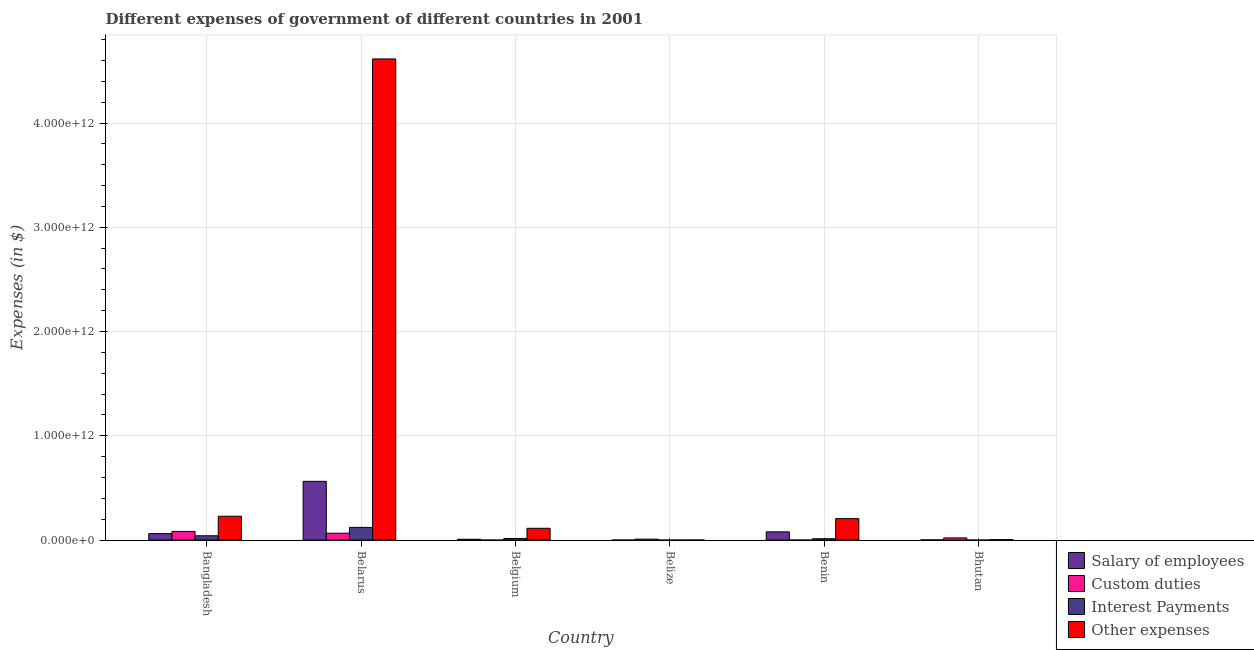Are the number of bars per tick equal to the number of legend labels?
Ensure brevity in your answer.  Yes. Are the number of bars on each tick of the X-axis equal?
Keep it short and to the point. Yes. How many bars are there on the 6th tick from the right?
Your answer should be very brief. 4. What is the label of the 6th group of bars from the left?
Give a very brief answer. Bhutan. In how many cases, is the number of bars for a given country not equal to the number of legend labels?
Offer a terse response. 0. What is the amount spent on custom duties in Belarus?
Offer a terse response. 6.60e+1. Across all countries, what is the maximum amount spent on salary of employees?
Provide a short and direct response. 5.64e+11. Across all countries, what is the minimum amount spent on interest payments?
Keep it short and to the point. 5.36e+07. In which country was the amount spent on other expenses maximum?
Provide a short and direct response. Belarus. In which country was the amount spent on custom duties minimum?
Give a very brief answer. Belgium. What is the total amount spent on other expenses in the graph?
Make the answer very short. 5.17e+12. What is the difference between the amount spent on interest payments in Belarus and that in Bhutan?
Your answer should be very brief. 1.22e+11. What is the difference between the amount spent on other expenses in Belarus and the amount spent on salary of employees in Belgium?
Your answer should be very brief. 4.61e+12. What is the average amount spent on interest payments per country?
Make the answer very short. 3.20e+1. What is the difference between the amount spent on salary of employees and amount spent on other expenses in Belize?
Your response must be concise. -2.12e+08. What is the ratio of the amount spent on interest payments in Belgium to that in Benin?
Give a very brief answer. 1.18. Is the difference between the amount spent on salary of employees in Bangladesh and Bhutan greater than the difference between the amount spent on custom duties in Bangladesh and Bhutan?
Ensure brevity in your answer.  No. What is the difference between the highest and the second highest amount spent on salary of employees?
Provide a short and direct response. 4.85e+11. What is the difference between the highest and the lowest amount spent on salary of employees?
Provide a short and direct response. 5.63e+11. Is the sum of the amount spent on interest payments in Belgium and Belize greater than the maximum amount spent on custom duties across all countries?
Offer a very short reply. No. Is it the case that in every country, the sum of the amount spent on custom duties and amount spent on salary of employees is greater than the sum of amount spent on interest payments and amount spent on other expenses?
Ensure brevity in your answer.  No. What does the 1st bar from the left in Benin represents?
Ensure brevity in your answer.  Salary of employees. What does the 1st bar from the right in Belarus represents?
Ensure brevity in your answer.  Other expenses. How many countries are there in the graph?
Make the answer very short. 6. What is the difference between two consecutive major ticks on the Y-axis?
Provide a short and direct response. 1.00e+12. Are the values on the major ticks of Y-axis written in scientific E-notation?
Your answer should be very brief. Yes. Does the graph contain any zero values?
Your answer should be very brief. No. Where does the legend appear in the graph?
Your answer should be compact. Bottom right. What is the title of the graph?
Keep it short and to the point. Different expenses of government of different countries in 2001. Does "Manufacturing" appear as one of the legend labels in the graph?
Keep it short and to the point. No. What is the label or title of the Y-axis?
Ensure brevity in your answer.  Expenses (in $). What is the Expenses (in $) of Salary of employees in Bangladesh?
Offer a very short reply. 6.23e+1. What is the Expenses (in $) in Custom duties in Bangladesh?
Provide a succinct answer. 8.33e+1. What is the Expenses (in $) of Interest Payments in Bangladesh?
Your answer should be very brief. 4.15e+1. What is the Expenses (in $) of Other expenses in Bangladesh?
Your answer should be compact. 2.29e+11. What is the Expenses (in $) in Salary of employees in Belarus?
Your response must be concise. 5.64e+11. What is the Expenses (in $) in Custom duties in Belarus?
Give a very brief answer. 6.60e+1. What is the Expenses (in $) of Interest Payments in Belarus?
Ensure brevity in your answer.  1.22e+11. What is the Expenses (in $) in Other expenses in Belarus?
Ensure brevity in your answer.  4.61e+12. What is the Expenses (in $) of Salary of employees in Belgium?
Give a very brief answer. 7.92e+09. What is the Expenses (in $) of Custom duties in Belgium?
Keep it short and to the point. 7.83e+07. What is the Expenses (in $) of Interest Payments in Belgium?
Offer a terse response. 1.55e+1. What is the Expenses (in $) in Other expenses in Belgium?
Make the answer very short. 1.13e+11. What is the Expenses (in $) of Salary of employees in Belize?
Your response must be concise. 1.64e+08. What is the Expenses (in $) in Custom duties in Belize?
Make the answer very short. 9.09e+09. What is the Expenses (in $) of Interest Payments in Belize?
Provide a short and direct response. 5.36e+07. What is the Expenses (in $) in Other expenses in Belize?
Your answer should be very brief. 3.75e+08. What is the Expenses (in $) of Salary of employees in Benin?
Offer a very short reply. 7.91e+1. What is the Expenses (in $) in Custom duties in Benin?
Keep it short and to the point. 1.95e+08. What is the Expenses (in $) of Interest Payments in Benin?
Provide a short and direct response. 1.32e+1. What is the Expenses (in $) of Other expenses in Benin?
Provide a short and direct response. 2.06e+11. What is the Expenses (in $) of Salary of employees in Bhutan?
Your answer should be compact. 1.72e+09. What is the Expenses (in $) of Custom duties in Bhutan?
Provide a short and direct response. 2.11e+1. What is the Expenses (in $) of Interest Payments in Bhutan?
Provide a succinct answer. 7.78e+07. What is the Expenses (in $) in Other expenses in Bhutan?
Your answer should be compact. 4.54e+09. Across all countries, what is the maximum Expenses (in $) of Salary of employees?
Make the answer very short. 5.64e+11. Across all countries, what is the maximum Expenses (in $) of Custom duties?
Make the answer very short. 8.33e+1. Across all countries, what is the maximum Expenses (in $) of Interest Payments?
Offer a terse response. 1.22e+11. Across all countries, what is the maximum Expenses (in $) of Other expenses?
Keep it short and to the point. 4.61e+12. Across all countries, what is the minimum Expenses (in $) of Salary of employees?
Give a very brief answer. 1.64e+08. Across all countries, what is the minimum Expenses (in $) of Custom duties?
Your response must be concise. 7.83e+07. Across all countries, what is the minimum Expenses (in $) of Interest Payments?
Offer a very short reply. 5.36e+07. Across all countries, what is the minimum Expenses (in $) of Other expenses?
Ensure brevity in your answer.  3.75e+08. What is the total Expenses (in $) of Salary of employees in the graph?
Make the answer very short. 7.15e+11. What is the total Expenses (in $) in Custom duties in the graph?
Offer a very short reply. 1.80e+11. What is the total Expenses (in $) in Interest Payments in the graph?
Your response must be concise. 1.92e+11. What is the total Expenses (in $) of Other expenses in the graph?
Offer a terse response. 5.17e+12. What is the difference between the Expenses (in $) of Salary of employees in Bangladesh and that in Belarus?
Your answer should be compact. -5.01e+11. What is the difference between the Expenses (in $) in Custom duties in Bangladesh and that in Belarus?
Offer a very short reply. 1.72e+1. What is the difference between the Expenses (in $) of Interest Payments in Bangladesh and that in Belarus?
Your answer should be very brief. -8.04e+1. What is the difference between the Expenses (in $) of Other expenses in Bangladesh and that in Belarus?
Provide a short and direct response. -4.39e+12. What is the difference between the Expenses (in $) of Salary of employees in Bangladesh and that in Belgium?
Offer a terse response. 5.44e+1. What is the difference between the Expenses (in $) of Custom duties in Bangladesh and that in Belgium?
Give a very brief answer. 8.32e+1. What is the difference between the Expenses (in $) of Interest Payments in Bangladesh and that in Belgium?
Offer a terse response. 2.59e+1. What is the difference between the Expenses (in $) in Other expenses in Bangladesh and that in Belgium?
Offer a very short reply. 1.16e+11. What is the difference between the Expenses (in $) of Salary of employees in Bangladesh and that in Belize?
Offer a very short reply. 6.22e+1. What is the difference between the Expenses (in $) in Custom duties in Bangladesh and that in Belize?
Offer a terse response. 7.42e+1. What is the difference between the Expenses (in $) of Interest Payments in Bangladesh and that in Belize?
Keep it short and to the point. 4.14e+1. What is the difference between the Expenses (in $) of Other expenses in Bangladesh and that in Belize?
Offer a terse response. 2.28e+11. What is the difference between the Expenses (in $) of Salary of employees in Bangladesh and that in Benin?
Provide a succinct answer. -1.68e+1. What is the difference between the Expenses (in $) of Custom duties in Bangladesh and that in Benin?
Give a very brief answer. 8.31e+1. What is the difference between the Expenses (in $) in Interest Payments in Bangladesh and that in Benin?
Offer a very short reply. 2.83e+1. What is the difference between the Expenses (in $) in Other expenses in Bangladesh and that in Benin?
Provide a short and direct response. 2.28e+1. What is the difference between the Expenses (in $) of Salary of employees in Bangladesh and that in Bhutan?
Offer a very short reply. 6.06e+1. What is the difference between the Expenses (in $) in Custom duties in Bangladesh and that in Bhutan?
Offer a terse response. 6.22e+1. What is the difference between the Expenses (in $) in Interest Payments in Bangladesh and that in Bhutan?
Provide a succinct answer. 4.14e+1. What is the difference between the Expenses (in $) in Other expenses in Bangladesh and that in Bhutan?
Provide a succinct answer. 2.24e+11. What is the difference between the Expenses (in $) in Salary of employees in Belarus and that in Belgium?
Offer a terse response. 5.56e+11. What is the difference between the Expenses (in $) in Custom duties in Belarus and that in Belgium?
Offer a terse response. 6.60e+1. What is the difference between the Expenses (in $) in Interest Payments in Belarus and that in Belgium?
Offer a terse response. 1.06e+11. What is the difference between the Expenses (in $) in Other expenses in Belarus and that in Belgium?
Offer a very short reply. 4.50e+12. What is the difference between the Expenses (in $) of Salary of employees in Belarus and that in Belize?
Give a very brief answer. 5.63e+11. What is the difference between the Expenses (in $) in Custom duties in Belarus and that in Belize?
Ensure brevity in your answer.  5.70e+1. What is the difference between the Expenses (in $) of Interest Payments in Belarus and that in Belize?
Provide a succinct answer. 1.22e+11. What is the difference between the Expenses (in $) of Other expenses in Belarus and that in Belize?
Ensure brevity in your answer.  4.61e+12. What is the difference between the Expenses (in $) of Salary of employees in Belarus and that in Benin?
Provide a succinct answer. 4.85e+11. What is the difference between the Expenses (in $) of Custom duties in Belarus and that in Benin?
Ensure brevity in your answer.  6.59e+1. What is the difference between the Expenses (in $) in Interest Payments in Belarus and that in Benin?
Offer a terse response. 1.09e+11. What is the difference between the Expenses (in $) of Other expenses in Belarus and that in Benin?
Offer a terse response. 4.41e+12. What is the difference between the Expenses (in $) of Salary of employees in Belarus and that in Bhutan?
Provide a short and direct response. 5.62e+11. What is the difference between the Expenses (in $) in Custom duties in Belarus and that in Bhutan?
Ensure brevity in your answer.  4.49e+1. What is the difference between the Expenses (in $) in Interest Payments in Belarus and that in Bhutan?
Give a very brief answer. 1.22e+11. What is the difference between the Expenses (in $) of Other expenses in Belarus and that in Bhutan?
Offer a very short reply. 4.61e+12. What is the difference between the Expenses (in $) of Salary of employees in Belgium and that in Belize?
Your answer should be compact. 7.75e+09. What is the difference between the Expenses (in $) in Custom duties in Belgium and that in Belize?
Ensure brevity in your answer.  -9.01e+09. What is the difference between the Expenses (in $) of Interest Payments in Belgium and that in Belize?
Your answer should be very brief. 1.55e+1. What is the difference between the Expenses (in $) of Other expenses in Belgium and that in Belize?
Provide a short and direct response. 1.13e+11. What is the difference between the Expenses (in $) of Salary of employees in Belgium and that in Benin?
Give a very brief answer. -7.12e+1. What is the difference between the Expenses (in $) in Custom duties in Belgium and that in Benin?
Your answer should be very brief. -1.17e+08. What is the difference between the Expenses (in $) in Interest Payments in Belgium and that in Benin?
Provide a succinct answer. 2.35e+09. What is the difference between the Expenses (in $) in Other expenses in Belgium and that in Benin?
Keep it short and to the point. -9.28e+1. What is the difference between the Expenses (in $) of Salary of employees in Belgium and that in Bhutan?
Offer a terse response. 6.19e+09. What is the difference between the Expenses (in $) of Custom duties in Belgium and that in Bhutan?
Provide a succinct answer. -2.10e+1. What is the difference between the Expenses (in $) of Interest Payments in Belgium and that in Bhutan?
Offer a very short reply. 1.55e+1. What is the difference between the Expenses (in $) of Other expenses in Belgium and that in Bhutan?
Make the answer very short. 1.09e+11. What is the difference between the Expenses (in $) of Salary of employees in Belize and that in Benin?
Give a very brief answer. -7.89e+1. What is the difference between the Expenses (in $) of Custom duties in Belize and that in Benin?
Your answer should be compact. 8.89e+09. What is the difference between the Expenses (in $) of Interest Payments in Belize and that in Benin?
Offer a terse response. -1.31e+1. What is the difference between the Expenses (in $) in Other expenses in Belize and that in Benin?
Ensure brevity in your answer.  -2.06e+11. What is the difference between the Expenses (in $) in Salary of employees in Belize and that in Bhutan?
Provide a succinct answer. -1.56e+09. What is the difference between the Expenses (in $) in Custom duties in Belize and that in Bhutan?
Offer a very short reply. -1.20e+1. What is the difference between the Expenses (in $) in Interest Payments in Belize and that in Bhutan?
Provide a short and direct response. -2.42e+07. What is the difference between the Expenses (in $) of Other expenses in Belize and that in Bhutan?
Provide a short and direct response. -4.16e+09. What is the difference between the Expenses (in $) of Salary of employees in Benin and that in Bhutan?
Keep it short and to the point. 7.74e+1. What is the difference between the Expenses (in $) of Custom duties in Benin and that in Bhutan?
Give a very brief answer. -2.09e+1. What is the difference between the Expenses (in $) of Interest Payments in Benin and that in Bhutan?
Provide a short and direct response. 1.31e+1. What is the difference between the Expenses (in $) in Other expenses in Benin and that in Bhutan?
Your answer should be compact. 2.01e+11. What is the difference between the Expenses (in $) of Salary of employees in Bangladesh and the Expenses (in $) of Custom duties in Belarus?
Your answer should be very brief. -3.73e+09. What is the difference between the Expenses (in $) of Salary of employees in Bangladesh and the Expenses (in $) of Interest Payments in Belarus?
Offer a very short reply. -5.96e+1. What is the difference between the Expenses (in $) in Salary of employees in Bangladesh and the Expenses (in $) in Other expenses in Belarus?
Keep it short and to the point. -4.55e+12. What is the difference between the Expenses (in $) in Custom duties in Bangladesh and the Expenses (in $) in Interest Payments in Belarus?
Keep it short and to the point. -3.86e+1. What is the difference between the Expenses (in $) of Custom duties in Bangladesh and the Expenses (in $) of Other expenses in Belarus?
Your answer should be very brief. -4.53e+12. What is the difference between the Expenses (in $) of Interest Payments in Bangladesh and the Expenses (in $) of Other expenses in Belarus?
Give a very brief answer. -4.57e+12. What is the difference between the Expenses (in $) of Salary of employees in Bangladesh and the Expenses (in $) of Custom duties in Belgium?
Your answer should be compact. 6.22e+1. What is the difference between the Expenses (in $) in Salary of employees in Bangladesh and the Expenses (in $) in Interest Payments in Belgium?
Make the answer very short. 4.68e+1. What is the difference between the Expenses (in $) in Salary of employees in Bangladesh and the Expenses (in $) in Other expenses in Belgium?
Ensure brevity in your answer.  -5.10e+1. What is the difference between the Expenses (in $) in Custom duties in Bangladesh and the Expenses (in $) in Interest Payments in Belgium?
Give a very brief answer. 6.77e+1. What is the difference between the Expenses (in $) in Custom duties in Bangladesh and the Expenses (in $) in Other expenses in Belgium?
Keep it short and to the point. -3.00e+1. What is the difference between the Expenses (in $) of Interest Payments in Bangladesh and the Expenses (in $) of Other expenses in Belgium?
Your answer should be very brief. -7.18e+1. What is the difference between the Expenses (in $) of Salary of employees in Bangladesh and the Expenses (in $) of Custom duties in Belize?
Offer a terse response. 5.32e+1. What is the difference between the Expenses (in $) of Salary of employees in Bangladesh and the Expenses (in $) of Interest Payments in Belize?
Provide a short and direct response. 6.23e+1. What is the difference between the Expenses (in $) in Salary of employees in Bangladesh and the Expenses (in $) in Other expenses in Belize?
Your answer should be compact. 6.19e+1. What is the difference between the Expenses (in $) in Custom duties in Bangladesh and the Expenses (in $) in Interest Payments in Belize?
Your response must be concise. 8.32e+1. What is the difference between the Expenses (in $) of Custom duties in Bangladesh and the Expenses (in $) of Other expenses in Belize?
Ensure brevity in your answer.  8.29e+1. What is the difference between the Expenses (in $) of Interest Payments in Bangladesh and the Expenses (in $) of Other expenses in Belize?
Make the answer very short. 4.11e+1. What is the difference between the Expenses (in $) in Salary of employees in Bangladesh and the Expenses (in $) in Custom duties in Benin?
Give a very brief answer. 6.21e+1. What is the difference between the Expenses (in $) in Salary of employees in Bangladesh and the Expenses (in $) in Interest Payments in Benin?
Make the answer very short. 4.91e+1. What is the difference between the Expenses (in $) of Salary of employees in Bangladesh and the Expenses (in $) of Other expenses in Benin?
Offer a very short reply. -1.44e+11. What is the difference between the Expenses (in $) of Custom duties in Bangladesh and the Expenses (in $) of Interest Payments in Benin?
Provide a succinct answer. 7.01e+1. What is the difference between the Expenses (in $) in Custom duties in Bangladesh and the Expenses (in $) in Other expenses in Benin?
Your answer should be very brief. -1.23e+11. What is the difference between the Expenses (in $) in Interest Payments in Bangladesh and the Expenses (in $) in Other expenses in Benin?
Keep it short and to the point. -1.65e+11. What is the difference between the Expenses (in $) in Salary of employees in Bangladesh and the Expenses (in $) in Custom duties in Bhutan?
Your answer should be very brief. 4.12e+1. What is the difference between the Expenses (in $) in Salary of employees in Bangladesh and the Expenses (in $) in Interest Payments in Bhutan?
Your answer should be very brief. 6.22e+1. What is the difference between the Expenses (in $) of Salary of employees in Bangladesh and the Expenses (in $) of Other expenses in Bhutan?
Your answer should be compact. 5.78e+1. What is the difference between the Expenses (in $) in Custom duties in Bangladesh and the Expenses (in $) in Interest Payments in Bhutan?
Your response must be concise. 8.32e+1. What is the difference between the Expenses (in $) in Custom duties in Bangladesh and the Expenses (in $) in Other expenses in Bhutan?
Provide a succinct answer. 7.87e+1. What is the difference between the Expenses (in $) in Interest Payments in Bangladesh and the Expenses (in $) in Other expenses in Bhutan?
Your answer should be compact. 3.69e+1. What is the difference between the Expenses (in $) of Salary of employees in Belarus and the Expenses (in $) of Custom duties in Belgium?
Provide a succinct answer. 5.64e+11. What is the difference between the Expenses (in $) of Salary of employees in Belarus and the Expenses (in $) of Interest Payments in Belgium?
Keep it short and to the point. 5.48e+11. What is the difference between the Expenses (in $) of Salary of employees in Belarus and the Expenses (in $) of Other expenses in Belgium?
Provide a short and direct response. 4.50e+11. What is the difference between the Expenses (in $) in Custom duties in Belarus and the Expenses (in $) in Interest Payments in Belgium?
Ensure brevity in your answer.  5.05e+1. What is the difference between the Expenses (in $) of Custom duties in Belarus and the Expenses (in $) of Other expenses in Belgium?
Offer a very short reply. -4.72e+1. What is the difference between the Expenses (in $) of Interest Payments in Belarus and the Expenses (in $) of Other expenses in Belgium?
Your answer should be very brief. 8.61e+09. What is the difference between the Expenses (in $) in Salary of employees in Belarus and the Expenses (in $) in Custom duties in Belize?
Your answer should be compact. 5.55e+11. What is the difference between the Expenses (in $) of Salary of employees in Belarus and the Expenses (in $) of Interest Payments in Belize?
Your answer should be very brief. 5.64e+11. What is the difference between the Expenses (in $) in Salary of employees in Belarus and the Expenses (in $) in Other expenses in Belize?
Your answer should be very brief. 5.63e+11. What is the difference between the Expenses (in $) of Custom duties in Belarus and the Expenses (in $) of Interest Payments in Belize?
Offer a terse response. 6.60e+1. What is the difference between the Expenses (in $) in Custom duties in Belarus and the Expenses (in $) in Other expenses in Belize?
Offer a very short reply. 6.57e+1. What is the difference between the Expenses (in $) of Interest Payments in Belarus and the Expenses (in $) of Other expenses in Belize?
Ensure brevity in your answer.  1.22e+11. What is the difference between the Expenses (in $) in Salary of employees in Belarus and the Expenses (in $) in Custom duties in Benin?
Give a very brief answer. 5.63e+11. What is the difference between the Expenses (in $) of Salary of employees in Belarus and the Expenses (in $) of Interest Payments in Benin?
Give a very brief answer. 5.50e+11. What is the difference between the Expenses (in $) in Salary of employees in Belarus and the Expenses (in $) in Other expenses in Benin?
Offer a terse response. 3.58e+11. What is the difference between the Expenses (in $) of Custom duties in Belarus and the Expenses (in $) of Interest Payments in Benin?
Offer a terse response. 5.29e+1. What is the difference between the Expenses (in $) in Custom duties in Belarus and the Expenses (in $) in Other expenses in Benin?
Ensure brevity in your answer.  -1.40e+11. What is the difference between the Expenses (in $) in Interest Payments in Belarus and the Expenses (in $) in Other expenses in Benin?
Keep it short and to the point. -8.41e+1. What is the difference between the Expenses (in $) in Salary of employees in Belarus and the Expenses (in $) in Custom duties in Bhutan?
Provide a short and direct response. 5.43e+11. What is the difference between the Expenses (in $) of Salary of employees in Belarus and the Expenses (in $) of Interest Payments in Bhutan?
Offer a very short reply. 5.64e+11. What is the difference between the Expenses (in $) of Salary of employees in Belarus and the Expenses (in $) of Other expenses in Bhutan?
Provide a succinct answer. 5.59e+11. What is the difference between the Expenses (in $) of Custom duties in Belarus and the Expenses (in $) of Interest Payments in Bhutan?
Offer a terse response. 6.60e+1. What is the difference between the Expenses (in $) of Custom duties in Belarus and the Expenses (in $) of Other expenses in Bhutan?
Give a very brief answer. 6.15e+1. What is the difference between the Expenses (in $) in Interest Payments in Belarus and the Expenses (in $) in Other expenses in Bhutan?
Offer a very short reply. 1.17e+11. What is the difference between the Expenses (in $) in Salary of employees in Belgium and the Expenses (in $) in Custom duties in Belize?
Make the answer very short. -1.17e+09. What is the difference between the Expenses (in $) of Salary of employees in Belgium and the Expenses (in $) of Interest Payments in Belize?
Keep it short and to the point. 7.86e+09. What is the difference between the Expenses (in $) in Salary of employees in Belgium and the Expenses (in $) in Other expenses in Belize?
Keep it short and to the point. 7.54e+09. What is the difference between the Expenses (in $) of Custom duties in Belgium and the Expenses (in $) of Interest Payments in Belize?
Your response must be concise. 2.47e+07. What is the difference between the Expenses (in $) of Custom duties in Belgium and the Expenses (in $) of Other expenses in Belize?
Provide a short and direct response. -2.97e+08. What is the difference between the Expenses (in $) of Interest Payments in Belgium and the Expenses (in $) of Other expenses in Belize?
Keep it short and to the point. 1.52e+1. What is the difference between the Expenses (in $) in Salary of employees in Belgium and the Expenses (in $) in Custom duties in Benin?
Give a very brief answer. 7.72e+09. What is the difference between the Expenses (in $) in Salary of employees in Belgium and the Expenses (in $) in Interest Payments in Benin?
Give a very brief answer. -5.26e+09. What is the difference between the Expenses (in $) in Salary of employees in Belgium and the Expenses (in $) in Other expenses in Benin?
Your response must be concise. -1.98e+11. What is the difference between the Expenses (in $) in Custom duties in Belgium and the Expenses (in $) in Interest Payments in Benin?
Keep it short and to the point. -1.31e+1. What is the difference between the Expenses (in $) of Custom duties in Belgium and the Expenses (in $) of Other expenses in Benin?
Your answer should be compact. -2.06e+11. What is the difference between the Expenses (in $) of Interest Payments in Belgium and the Expenses (in $) of Other expenses in Benin?
Keep it short and to the point. -1.90e+11. What is the difference between the Expenses (in $) of Salary of employees in Belgium and the Expenses (in $) of Custom duties in Bhutan?
Your response must be concise. -1.32e+1. What is the difference between the Expenses (in $) of Salary of employees in Belgium and the Expenses (in $) of Interest Payments in Bhutan?
Give a very brief answer. 7.84e+09. What is the difference between the Expenses (in $) of Salary of employees in Belgium and the Expenses (in $) of Other expenses in Bhutan?
Provide a succinct answer. 3.38e+09. What is the difference between the Expenses (in $) in Custom duties in Belgium and the Expenses (in $) in Other expenses in Bhutan?
Your response must be concise. -4.46e+09. What is the difference between the Expenses (in $) of Interest Payments in Belgium and the Expenses (in $) of Other expenses in Bhutan?
Your answer should be compact. 1.10e+1. What is the difference between the Expenses (in $) of Salary of employees in Belize and the Expenses (in $) of Custom duties in Benin?
Offer a very short reply. -3.18e+07. What is the difference between the Expenses (in $) in Salary of employees in Belize and the Expenses (in $) in Interest Payments in Benin?
Ensure brevity in your answer.  -1.30e+1. What is the difference between the Expenses (in $) of Salary of employees in Belize and the Expenses (in $) of Other expenses in Benin?
Offer a terse response. -2.06e+11. What is the difference between the Expenses (in $) of Custom duties in Belize and the Expenses (in $) of Interest Payments in Benin?
Your answer should be very brief. -4.09e+09. What is the difference between the Expenses (in $) in Custom duties in Belize and the Expenses (in $) in Other expenses in Benin?
Your answer should be compact. -1.97e+11. What is the difference between the Expenses (in $) in Interest Payments in Belize and the Expenses (in $) in Other expenses in Benin?
Ensure brevity in your answer.  -2.06e+11. What is the difference between the Expenses (in $) in Salary of employees in Belize and the Expenses (in $) in Custom duties in Bhutan?
Make the answer very short. -2.09e+1. What is the difference between the Expenses (in $) in Salary of employees in Belize and the Expenses (in $) in Interest Payments in Bhutan?
Your answer should be very brief. 8.58e+07. What is the difference between the Expenses (in $) in Salary of employees in Belize and the Expenses (in $) in Other expenses in Bhutan?
Provide a short and direct response. -4.37e+09. What is the difference between the Expenses (in $) in Custom duties in Belize and the Expenses (in $) in Interest Payments in Bhutan?
Your answer should be very brief. 9.01e+09. What is the difference between the Expenses (in $) of Custom duties in Belize and the Expenses (in $) of Other expenses in Bhutan?
Your response must be concise. 4.55e+09. What is the difference between the Expenses (in $) of Interest Payments in Belize and the Expenses (in $) of Other expenses in Bhutan?
Give a very brief answer. -4.48e+09. What is the difference between the Expenses (in $) of Salary of employees in Benin and the Expenses (in $) of Custom duties in Bhutan?
Offer a terse response. 5.80e+1. What is the difference between the Expenses (in $) of Salary of employees in Benin and the Expenses (in $) of Interest Payments in Bhutan?
Your answer should be compact. 7.90e+1. What is the difference between the Expenses (in $) of Salary of employees in Benin and the Expenses (in $) of Other expenses in Bhutan?
Provide a short and direct response. 7.46e+1. What is the difference between the Expenses (in $) of Custom duties in Benin and the Expenses (in $) of Interest Payments in Bhutan?
Keep it short and to the point. 1.18e+08. What is the difference between the Expenses (in $) in Custom duties in Benin and the Expenses (in $) in Other expenses in Bhutan?
Ensure brevity in your answer.  -4.34e+09. What is the difference between the Expenses (in $) of Interest Payments in Benin and the Expenses (in $) of Other expenses in Bhutan?
Offer a very short reply. 8.64e+09. What is the average Expenses (in $) in Salary of employees per country?
Offer a terse response. 1.19e+11. What is the average Expenses (in $) of Custom duties per country?
Offer a very short reply. 3.00e+1. What is the average Expenses (in $) of Interest Payments per country?
Provide a short and direct response. 3.20e+1. What is the average Expenses (in $) in Other expenses per country?
Give a very brief answer. 8.61e+11. What is the difference between the Expenses (in $) of Salary of employees and Expenses (in $) of Custom duties in Bangladesh?
Keep it short and to the point. -2.10e+1. What is the difference between the Expenses (in $) in Salary of employees and Expenses (in $) in Interest Payments in Bangladesh?
Provide a short and direct response. 2.09e+1. What is the difference between the Expenses (in $) in Salary of employees and Expenses (in $) in Other expenses in Bangladesh?
Your response must be concise. -1.66e+11. What is the difference between the Expenses (in $) in Custom duties and Expenses (in $) in Interest Payments in Bangladesh?
Your answer should be very brief. 4.18e+1. What is the difference between the Expenses (in $) in Custom duties and Expenses (in $) in Other expenses in Bangladesh?
Make the answer very short. -1.46e+11. What is the difference between the Expenses (in $) of Interest Payments and Expenses (in $) of Other expenses in Bangladesh?
Provide a short and direct response. -1.87e+11. What is the difference between the Expenses (in $) of Salary of employees and Expenses (in $) of Custom duties in Belarus?
Keep it short and to the point. 4.98e+11. What is the difference between the Expenses (in $) in Salary of employees and Expenses (in $) in Interest Payments in Belarus?
Your answer should be very brief. 4.42e+11. What is the difference between the Expenses (in $) of Salary of employees and Expenses (in $) of Other expenses in Belarus?
Provide a succinct answer. -4.05e+12. What is the difference between the Expenses (in $) of Custom duties and Expenses (in $) of Interest Payments in Belarus?
Ensure brevity in your answer.  -5.58e+1. What is the difference between the Expenses (in $) of Custom duties and Expenses (in $) of Other expenses in Belarus?
Make the answer very short. -4.55e+12. What is the difference between the Expenses (in $) in Interest Payments and Expenses (in $) in Other expenses in Belarus?
Provide a succinct answer. -4.49e+12. What is the difference between the Expenses (in $) of Salary of employees and Expenses (in $) of Custom duties in Belgium?
Make the answer very short. 7.84e+09. What is the difference between the Expenses (in $) of Salary of employees and Expenses (in $) of Interest Payments in Belgium?
Your answer should be compact. -7.61e+09. What is the difference between the Expenses (in $) of Salary of employees and Expenses (in $) of Other expenses in Belgium?
Your answer should be compact. -1.05e+11. What is the difference between the Expenses (in $) of Custom duties and Expenses (in $) of Interest Payments in Belgium?
Offer a very short reply. -1.55e+1. What is the difference between the Expenses (in $) in Custom duties and Expenses (in $) in Other expenses in Belgium?
Provide a short and direct response. -1.13e+11. What is the difference between the Expenses (in $) in Interest Payments and Expenses (in $) in Other expenses in Belgium?
Make the answer very short. -9.77e+1. What is the difference between the Expenses (in $) of Salary of employees and Expenses (in $) of Custom duties in Belize?
Offer a terse response. -8.92e+09. What is the difference between the Expenses (in $) in Salary of employees and Expenses (in $) in Interest Payments in Belize?
Your answer should be compact. 1.10e+08. What is the difference between the Expenses (in $) in Salary of employees and Expenses (in $) in Other expenses in Belize?
Your answer should be very brief. -2.12e+08. What is the difference between the Expenses (in $) of Custom duties and Expenses (in $) of Interest Payments in Belize?
Make the answer very short. 9.03e+09. What is the difference between the Expenses (in $) in Custom duties and Expenses (in $) in Other expenses in Belize?
Offer a very short reply. 8.71e+09. What is the difference between the Expenses (in $) of Interest Payments and Expenses (in $) of Other expenses in Belize?
Make the answer very short. -3.21e+08. What is the difference between the Expenses (in $) of Salary of employees and Expenses (in $) of Custom duties in Benin?
Your answer should be compact. 7.89e+1. What is the difference between the Expenses (in $) of Salary of employees and Expenses (in $) of Interest Payments in Benin?
Give a very brief answer. 6.59e+1. What is the difference between the Expenses (in $) in Salary of employees and Expenses (in $) in Other expenses in Benin?
Offer a terse response. -1.27e+11. What is the difference between the Expenses (in $) in Custom duties and Expenses (in $) in Interest Payments in Benin?
Make the answer very short. -1.30e+1. What is the difference between the Expenses (in $) in Custom duties and Expenses (in $) in Other expenses in Benin?
Your answer should be compact. -2.06e+11. What is the difference between the Expenses (in $) in Interest Payments and Expenses (in $) in Other expenses in Benin?
Provide a succinct answer. -1.93e+11. What is the difference between the Expenses (in $) of Salary of employees and Expenses (in $) of Custom duties in Bhutan?
Offer a very short reply. -1.94e+1. What is the difference between the Expenses (in $) of Salary of employees and Expenses (in $) of Interest Payments in Bhutan?
Your response must be concise. 1.65e+09. What is the difference between the Expenses (in $) of Salary of employees and Expenses (in $) of Other expenses in Bhutan?
Provide a short and direct response. -2.81e+09. What is the difference between the Expenses (in $) of Custom duties and Expenses (in $) of Interest Payments in Bhutan?
Keep it short and to the point. 2.10e+1. What is the difference between the Expenses (in $) in Custom duties and Expenses (in $) in Other expenses in Bhutan?
Make the answer very short. 1.66e+1. What is the difference between the Expenses (in $) of Interest Payments and Expenses (in $) of Other expenses in Bhutan?
Ensure brevity in your answer.  -4.46e+09. What is the ratio of the Expenses (in $) in Salary of employees in Bangladesh to that in Belarus?
Offer a very short reply. 0.11. What is the ratio of the Expenses (in $) in Custom duties in Bangladesh to that in Belarus?
Offer a terse response. 1.26. What is the ratio of the Expenses (in $) of Interest Payments in Bangladesh to that in Belarus?
Your response must be concise. 0.34. What is the ratio of the Expenses (in $) in Other expenses in Bangladesh to that in Belarus?
Give a very brief answer. 0.05. What is the ratio of the Expenses (in $) of Salary of employees in Bangladesh to that in Belgium?
Provide a short and direct response. 7.87. What is the ratio of the Expenses (in $) in Custom duties in Bangladesh to that in Belgium?
Your response must be concise. 1063.56. What is the ratio of the Expenses (in $) of Interest Payments in Bangladesh to that in Belgium?
Provide a short and direct response. 2.67. What is the ratio of the Expenses (in $) in Other expenses in Bangladesh to that in Belgium?
Your answer should be very brief. 2.02. What is the ratio of the Expenses (in $) of Salary of employees in Bangladesh to that in Belize?
Your response must be concise. 380.97. What is the ratio of the Expenses (in $) of Custom duties in Bangladesh to that in Belize?
Keep it short and to the point. 9.16. What is the ratio of the Expenses (in $) in Interest Payments in Bangladesh to that in Belize?
Your response must be concise. 772.95. What is the ratio of the Expenses (in $) of Other expenses in Bangladesh to that in Belize?
Keep it short and to the point. 609.92. What is the ratio of the Expenses (in $) of Salary of employees in Bangladesh to that in Benin?
Offer a terse response. 0.79. What is the ratio of the Expenses (in $) of Custom duties in Bangladesh to that in Benin?
Offer a terse response. 426.2. What is the ratio of the Expenses (in $) in Interest Payments in Bangladesh to that in Benin?
Your answer should be very brief. 3.15. What is the ratio of the Expenses (in $) of Other expenses in Bangladesh to that in Benin?
Your response must be concise. 1.11. What is the ratio of the Expenses (in $) of Salary of employees in Bangladesh to that in Bhutan?
Ensure brevity in your answer.  36.17. What is the ratio of the Expenses (in $) in Custom duties in Bangladesh to that in Bhutan?
Provide a succinct answer. 3.94. What is the ratio of the Expenses (in $) of Interest Payments in Bangladesh to that in Bhutan?
Your response must be concise. 532.86. What is the ratio of the Expenses (in $) of Other expenses in Bangladesh to that in Bhutan?
Provide a succinct answer. 50.42. What is the ratio of the Expenses (in $) of Salary of employees in Belarus to that in Belgium?
Provide a succinct answer. 71.2. What is the ratio of the Expenses (in $) in Custom duties in Belarus to that in Belgium?
Provide a succinct answer. 843.5. What is the ratio of the Expenses (in $) in Interest Payments in Belarus to that in Belgium?
Offer a terse response. 7.85. What is the ratio of the Expenses (in $) of Other expenses in Belarus to that in Belgium?
Give a very brief answer. 40.74. What is the ratio of the Expenses (in $) in Salary of employees in Belarus to that in Belize?
Keep it short and to the point. 3445.59. What is the ratio of the Expenses (in $) of Custom duties in Belarus to that in Belize?
Ensure brevity in your answer.  7.27. What is the ratio of the Expenses (in $) of Interest Payments in Belarus to that in Belize?
Offer a terse response. 2272.44. What is the ratio of the Expenses (in $) in Other expenses in Belarus to that in Belize?
Provide a short and direct response. 1.23e+04. What is the ratio of the Expenses (in $) of Salary of employees in Belarus to that in Benin?
Your response must be concise. 7.13. What is the ratio of the Expenses (in $) in Custom duties in Belarus to that in Benin?
Your response must be concise. 338.01. What is the ratio of the Expenses (in $) of Interest Payments in Belarus to that in Benin?
Provide a short and direct response. 9.25. What is the ratio of the Expenses (in $) of Other expenses in Belarus to that in Benin?
Ensure brevity in your answer.  22.4. What is the ratio of the Expenses (in $) of Salary of employees in Belarus to that in Bhutan?
Your answer should be very brief. 327.13. What is the ratio of the Expenses (in $) of Custom duties in Belarus to that in Bhutan?
Offer a terse response. 3.13. What is the ratio of the Expenses (in $) of Interest Payments in Belarus to that in Bhutan?
Provide a short and direct response. 1566.58. What is the ratio of the Expenses (in $) of Other expenses in Belarus to that in Bhutan?
Offer a terse response. 1017.02. What is the ratio of the Expenses (in $) of Salary of employees in Belgium to that in Belize?
Your answer should be very brief. 48.4. What is the ratio of the Expenses (in $) of Custom duties in Belgium to that in Belize?
Offer a terse response. 0.01. What is the ratio of the Expenses (in $) in Interest Payments in Belgium to that in Belize?
Provide a succinct answer. 289.56. What is the ratio of the Expenses (in $) in Other expenses in Belgium to that in Belize?
Your answer should be compact. 301.99. What is the ratio of the Expenses (in $) in Salary of employees in Belgium to that in Benin?
Provide a short and direct response. 0.1. What is the ratio of the Expenses (in $) of Custom duties in Belgium to that in Benin?
Your answer should be compact. 0.4. What is the ratio of the Expenses (in $) in Interest Payments in Belgium to that in Benin?
Give a very brief answer. 1.18. What is the ratio of the Expenses (in $) of Other expenses in Belgium to that in Benin?
Your answer should be very brief. 0.55. What is the ratio of the Expenses (in $) of Salary of employees in Belgium to that in Bhutan?
Make the answer very short. 4.59. What is the ratio of the Expenses (in $) in Custom duties in Belgium to that in Bhutan?
Offer a very short reply. 0. What is the ratio of the Expenses (in $) in Interest Payments in Belgium to that in Bhutan?
Make the answer very short. 199.62. What is the ratio of the Expenses (in $) in Other expenses in Belgium to that in Bhutan?
Offer a terse response. 24.96. What is the ratio of the Expenses (in $) of Salary of employees in Belize to that in Benin?
Make the answer very short. 0. What is the ratio of the Expenses (in $) of Custom duties in Belize to that in Benin?
Ensure brevity in your answer.  46.51. What is the ratio of the Expenses (in $) in Interest Payments in Belize to that in Benin?
Make the answer very short. 0. What is the ratio of the Expenses (in $) of Other expenses in Belize to that in Benin?
Offer a terse response. 0. What is the ratio of the Expenses (in $) of Salary of employees in Belize to that in Bhutan?
Your answer should be compact. 0.09. What is the ratio of the Expenses (in $) in Custom duties in Belize to that in Bhutan?
Keep it short and to the point. 0.43. What is the ratio of the Expenses (in $) in Interest Payments in Belize to that in Bhutan?
Your response must be concise. 0.69. What is the ratio of the Expenses (in $) in Other expenses in Belize to that in Bhutan?
Make the answer very short. 0.08. What is the ratio of the Expenses (in $) in Salary of employees in Benin to that in Bhutan?
Ensure brevity in your answer.  45.91. What is the ratio of the Expenses (in $) in Custom duties in Benin to that in Bhutan?
Make the answer very short. 0.01. What is the ratio of the Expenses (in $) of Interest Payments in Benin to that in Bhutan?
Your answer should be very brief. 169.38. What is the ratio of the Expenses (in $) in Other expenses in Benin to that in Bhutan?
Provide a short and direct response. 45.41. What is the difference between the highest and the second highest Expenses (in $) in Salary of employees?
Offer a terse response. 4.85e+11. What is the difference between the highest and the second highest Expenses (in $) of Custom duties?
Keep it short and to the point. 1.72e+1. What is the difference between the highest and the second highest Expenses (in $) of Interest Payments?
Your answer should be very brief. 8.04e+1. What is the difference between the highest and the second highest Expenses (in $) of Other expenses?
Provide a short and direct response. 4.39e+12. What is the difference between the highest and the lowest Expenses (in $) of Salary of employees?
Offer a very short reply. 5.63e+11. What is the difference between the highest and the lowest Expenses (in $) in Custom duties?
Give a very brief answer. 8.32e+1. What is the difference between the highest and the lowest Expenses (in $) in Interest Payments?
Keep it short and to the point. 1.22e+11. What is the difference between the highest and the lowest Expenses (in $) in Other expenses?
Your answer should be compact. 4.61e+12. 